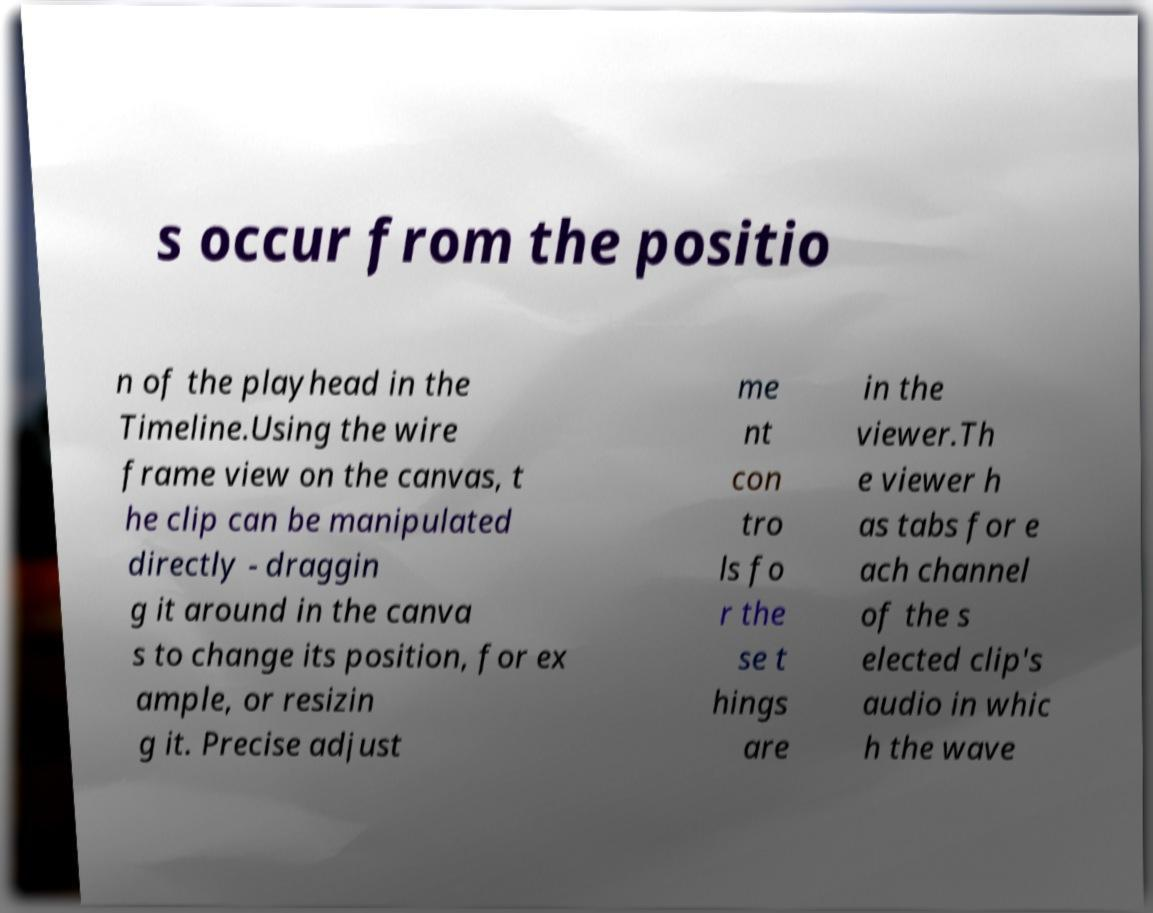There's text embedded in this image that I need extracted. Can you transcribe it verbatim? s occur from the positio n of the playhead in the Timeline.Using the wire frame view on the canvas, t he clip can be manipulated directly - draggin g it around in the canva s to change its position, for ex ample, or resizin g it. Precise adjust me nt con tro ls fo r the se t hings are in the viewer.Th e viewer h as tabs for e ach channel of the s elected clip's audio in whic h the wave 